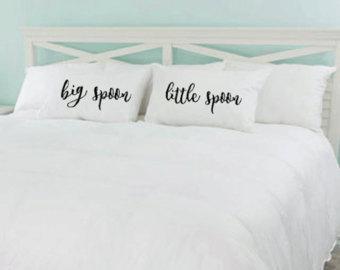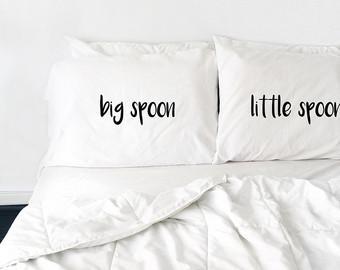The first image is the image on the left, the second image is the image on the right. Considering the images on both sides, is "The writing in the right image is cursive." valid? Answer yes or no. No. The first image is the image on the left, the second image is the image on the right. Examine the images to the left and right. Is the description "Each image shows a pair of pillows with text only, side-by-side on a bed with all-white bedding." accurate? Answer yes or no. Yes. 